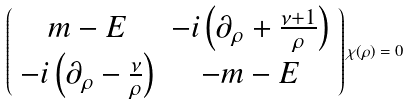Convert formula to latex. <formula><loc_0><loc_0><loc_500><loc_500>\left ( \begin{array} { c c } m - E & - i \left ( \partial _ { \rho } + \frac { \nu + 1 } { \rho } \right ) \\ - i \left ( \partial _ { \rho } - \frac { \nu } { \rho } \right ) & - m - E \end{array} \right ) \chi ( \rho ) = 0</formula> 